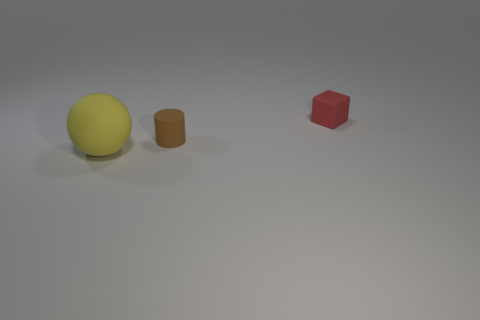Is there anything else that has the same size as the red object?
Offer a terse response. Yes. What number of cylinders are either brown rubber things or big purple matte objects?
Give a very brief answer. 1. There is a matte thing that is right of the small matte object that is left of the tiny red thing; what is its color?
Provide a short and direct response. Red. The yellow rubber thing has what shape?
Your response must be concise. Sphere. There is a object to the right of the brown cylinder; is it the same size as the small matte cylinder?
Give a very brief answer. Yes. Are there any large red things made of the same material as the yellow object?
Give a very brief answer. No. How many things are either objects in front of the brown rubber cylinder or big yellow matte spheres?
Give a very brief answer. 1. Is there a red matte block?
Your answer should be very brief. Yes. What is the shape of the thing that is both in front of the tiny red rubber cube and right of the big object?
Ensure brevity in your answer.  Cylinder. There is a object right of the small matte cylinder; how big is it?
Provide a succinct answer. Small. 